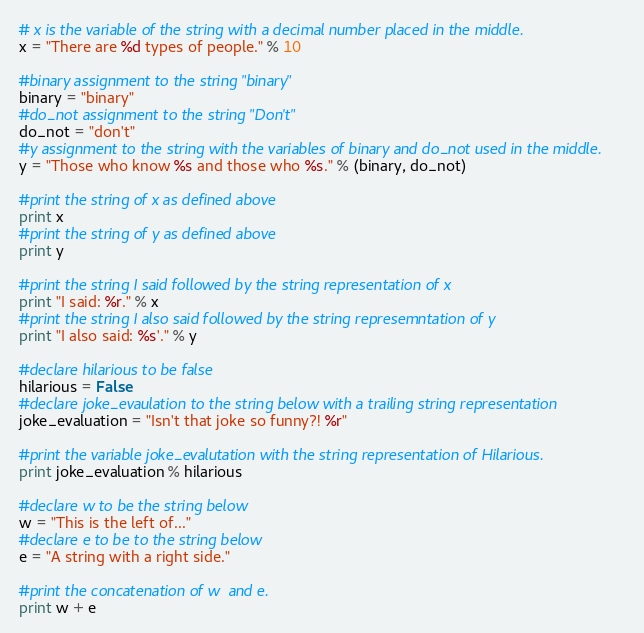<code> <loc_0><loc_0><loc_500><loc_500><_Python_># x is the variable of the string with a decimal number placed in the middle.
x = "There are %d types of people." % 10

#binary assignment to the string "binary"
binary = "binary"
#do_not assignment to the string "Don't"
do_not = "don't"
#y assignment to the string with the variables of binary and do_not used in the middle.
y = "Those who know %s and those who %s." % (binary, do_not)

#print the string of x as defined above
print x
#print the string of y as defined above
print y

#print the string I said followed by the string representation of x
print "I said: %r." % x
#print the string I also said followed by the string represemntation of y
print "I also said: %s'." % y

#declare hilarious to be false
hilarious = False
#declare joke_evaulation to the string below with a trailing string representation
joke_evaluation = "Isn't that joke so funny?! %r"

#print the variable joke_evalutation with the string representation of Hilarious. 
print joke_evaluation % hilarious

#declare w to be the string below
w = "This is the left of..."
#declare e to be to the string below
e = "A string with a right side."

#print the concatenation of w  and e.
print w + e</code> 